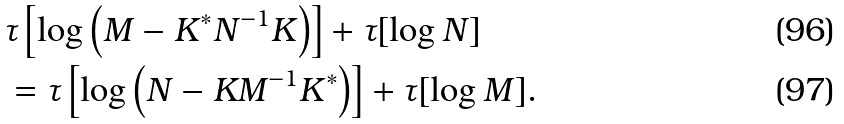<formula> <loc_0><loc_0><loc_500><loc_500>& \tau \left [ \log \left ( M - K ^ { * } N ^ { - 1 } K \right ) \right ] + \tau [ \log N ] \\ & = \tau \left [ \log \left ( N - K M ^ { - 1 } K ^ { * } \right ) \right ] + \tau [ \log M ] .</formula> 